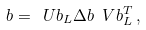Convert formula to latex. <formula><loc_0><loc_0><loc_500><loc_500>\L b = \ U b _ { L } \Delta b \ V b _ { L } ^ { T } \, ,</formula> 